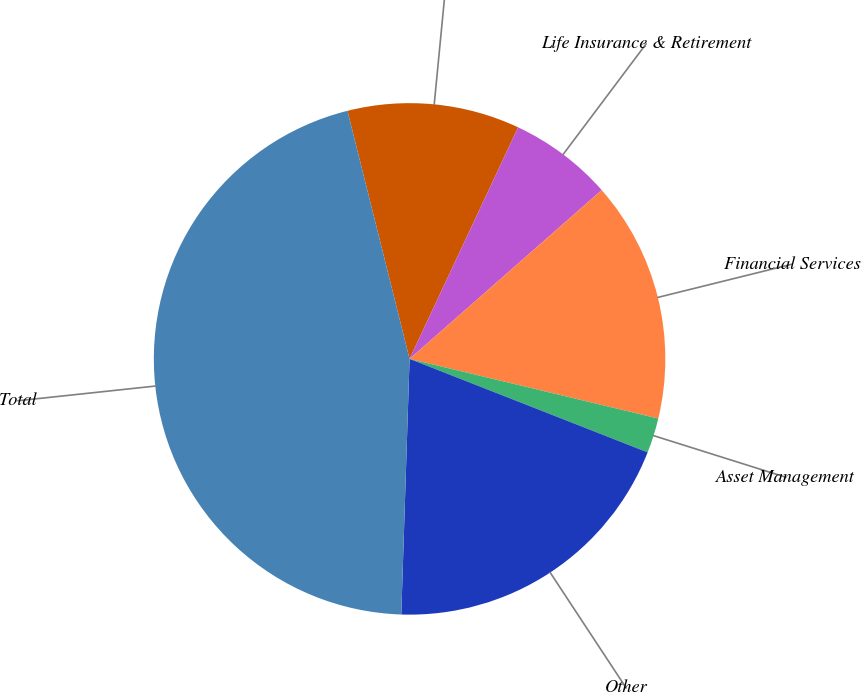Convert chart to OTSL. <chart><loc_0><loc_0><loc_500><loc_500><pie_chart><fcel>General Insurance<fcel>Life Insurance & Retirement<fcel>Financial Services<fcel>Asset Management<fcel>Other<fcel>Total<nl><fcel>10.88%<fcel>6.55%<fcel>15.22%<fcel>2.21%<fcel>19.56%<fcel>45.58%<nl></chart> 